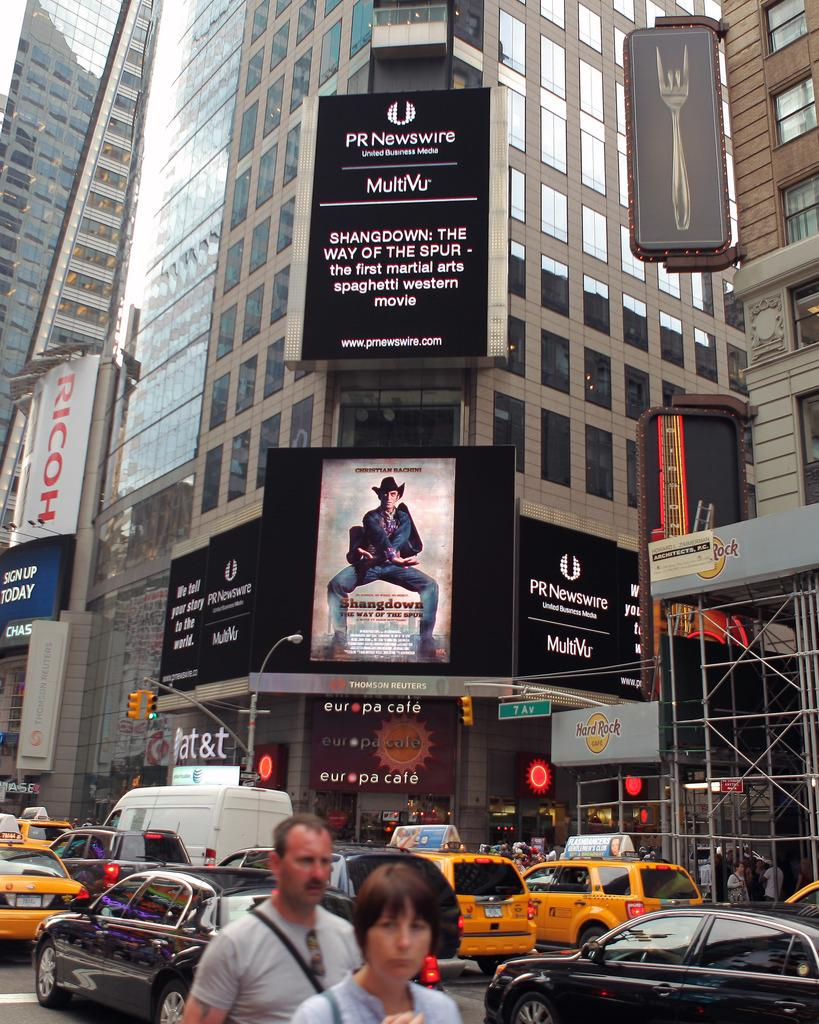<image>
Write a terse but informative summary of the picture. Europa Cafe  is on the corner in this metro area. 